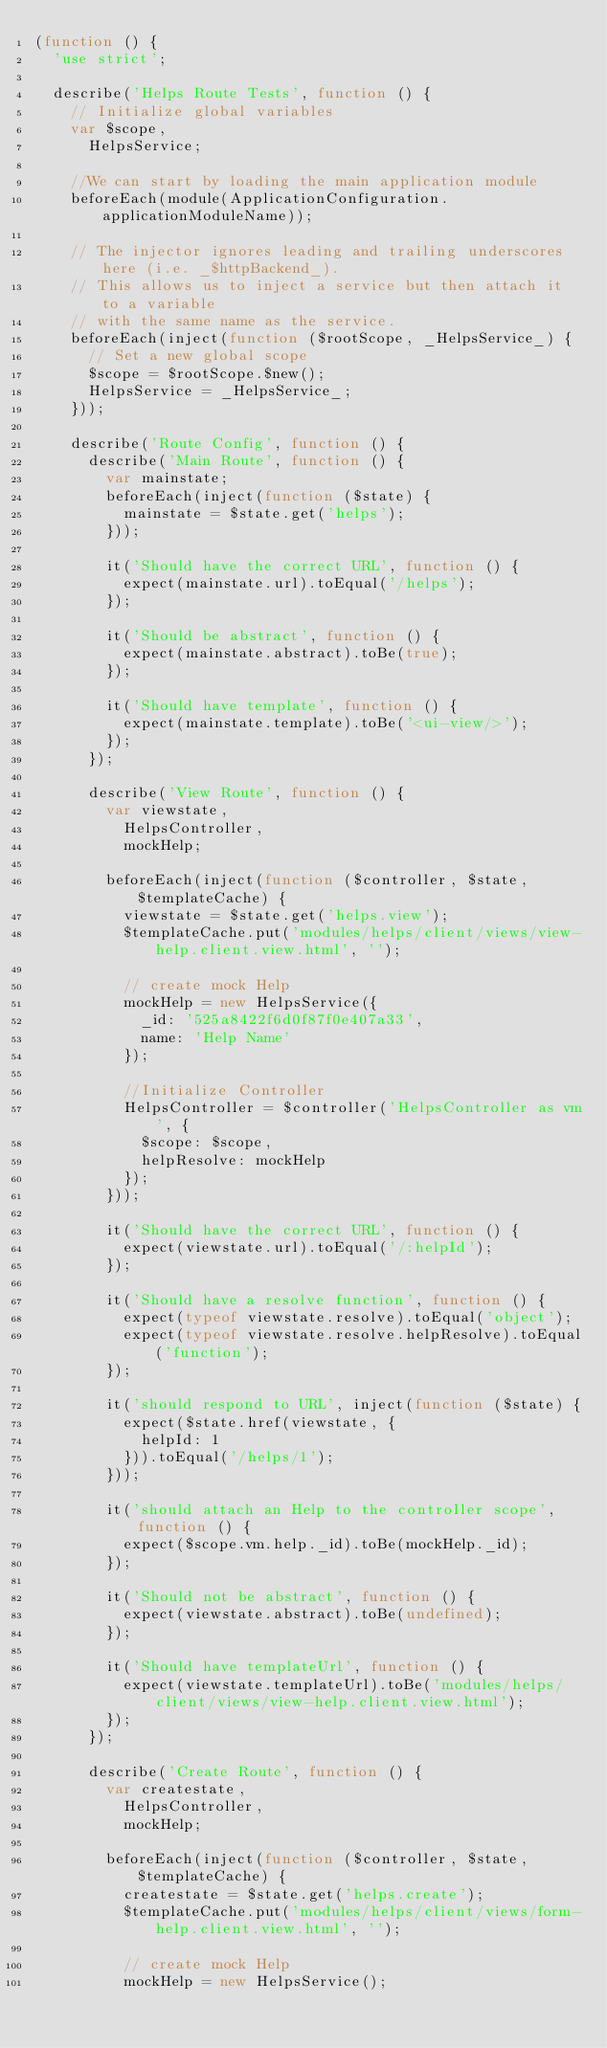Convert code to text. <code><loc_0><loc_0><loc_500><loc_500><_JavaScript_>(function () {
  'use strict';

  describe('Helps Route Tests', function () {
    // Initialize global variables
    var $scope,
      HelpsService;

    //We can start by loading the main application module
    beforeEach(module(ApplicationConfiguration.applicationModuleName));

    // The injector ignores leading and trailing underscores here (i.e. _$httpBackend_).
    // This allows us to inject a service but then attach it to a variable
    // with the same name as the service.
    beforeEach(inject(function ($rootScope, _HelpsService_) {
      // Set a new global scope
      $scope = $rootScope.$new();
      HelpsService = _HelpsService_;
    }));

    describe('Route Config', function () {
      describe('Main Route', function () {
        var mainstate;
        beforeEach(inject(function ($state) {
          mainstate = $state.get('helps');
        }));

        it('Should have the correct URL', function () {
          expect(mainstate.url).toEqual('/helps');
        });

        it('Should be abstract', function () {
          expect(mainstate.abstract).toBe(true);
        });

        it('Should have template', function () {
          expect(mainstate.template).toBe('<ui-view/>');
        });
      });

      describe('View Route', function () {
        var viewstate,
          HelpsController,
          mockHelp;

        beforeEach(inject(function ($controller, $state, $templateCache) {
          viewstate = $state.get('helps.view');
          $templateCache.put('modules/helps/client/views/view-help.client.view.html', '');

          // create mock Help
          mockHelp = new HelpsService({
            _id: '525a8422f6d0f87f0e407a33',
            name: 'Help Name'
          });

          //Initialize Controller
          HelpsController = $controller('HelpsController as vm', {
            $scope: $scope,
            helpResolve: mockHelp
          });
        }));

        it('Should have the correct URL', function () {
          expect(viewstate.url).toEqual('/:helpId');
        });

        it('Should have a resolve function', function () {
          expect(typeof viewstate.resolve).toEqual('object');
          expect(typeof viewstate.resolve.helpResolve).toEqual('function');
        });

        it('should respond to URL', inject(function ($state) {
          expect($state.href(viewstate, {
            helpId: 1
          })).toEqual('/helps/1');
        }));

        it('should attach an Help to the controller scope', function () {
          expect($scope.vm.help._id).toBe(mockHelp._id);
        });

        it('Should not be abstract', function () {
          expect(viewstate.abstract).toBe(undefined);
        });

        it('Should have templateUrl', function () {
          expect(viewstate.templateUrl).toBe('modules/helps/client/views/view-help.client.view.html');
        });
      });

      describe('Create Route', function () {
        var createstate,
          HelpsController,
          mockHelp;

        beforeEach(inject(function ($controller, $state, $templateCache) {
          createstate = $state.get('helps.create');
          $templateCache.put('modules/helps/client/views/form-help.client.view.html', '');

          // create mock Help
          mockHelp = new HelpsService();
</code> 